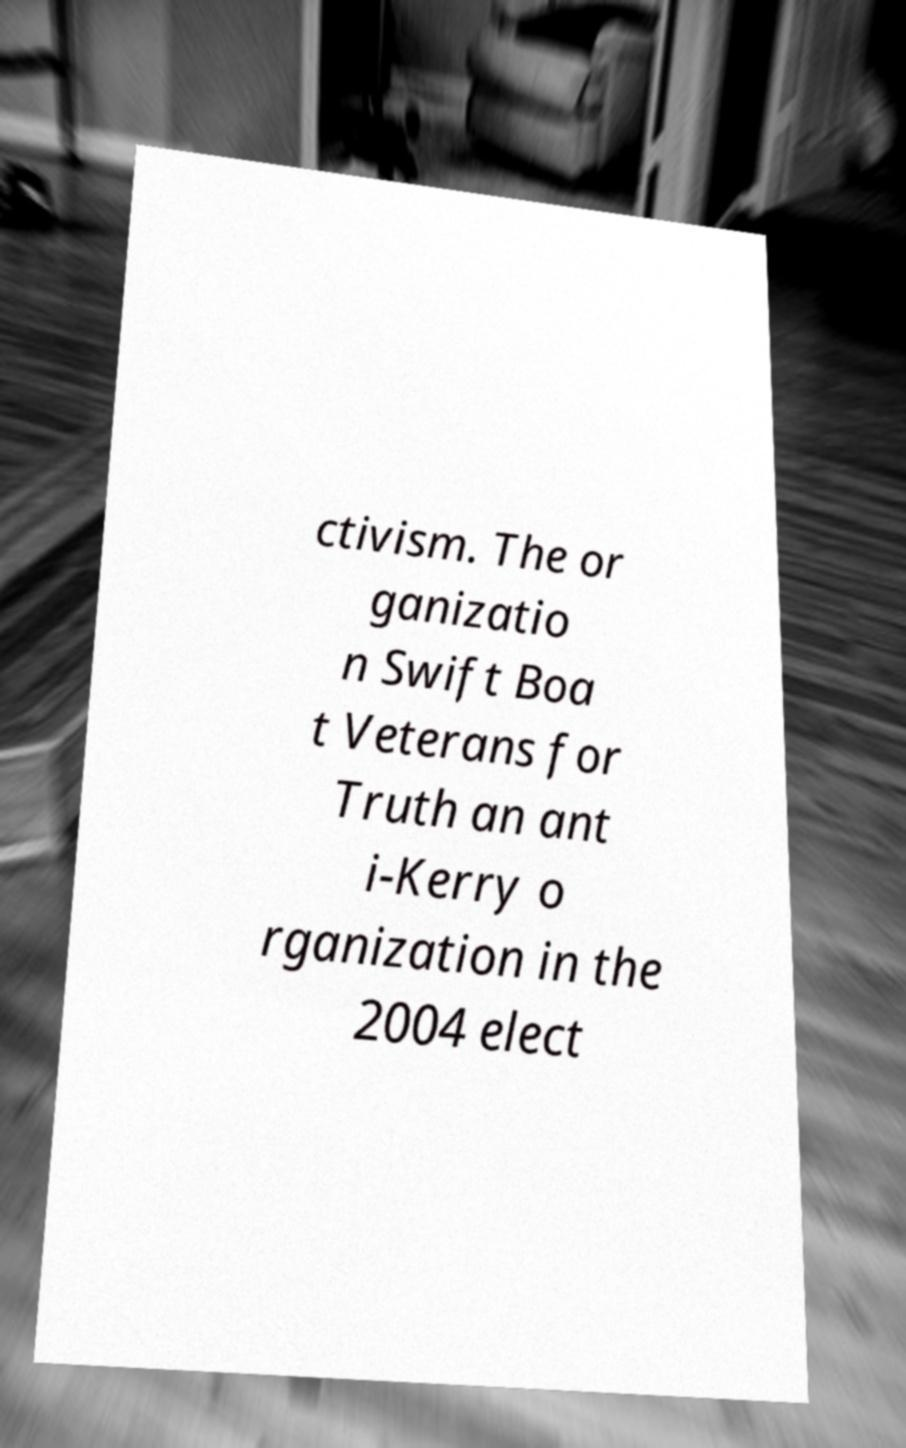Please identify and transcribe the text found in this image. ctivism. The or ganizatio n Swift Boa t Veterans for Truth an ant i-Kerry o rganization in the 2004 elect 